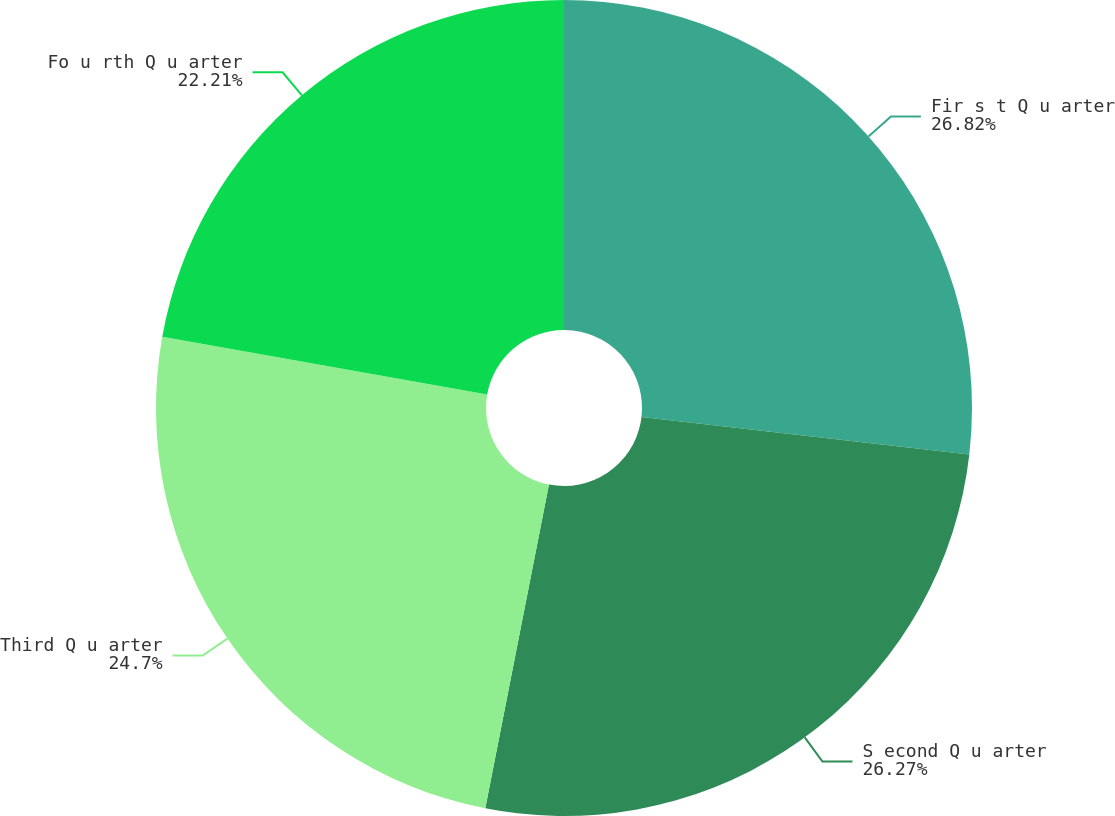Convert chart. <chart><loc_0><loc_0><loc_500><loc_500><pie_chart><fcel>Fir s t Q u arter<fcel>S econd Q u arter<fcel>Third Q u arter<fcel>Fo u rth Q u arter<nl><fcel>26.82%<fcel>26.27%<fcel>24.7%<fcel>22.21%<nl></chart> 